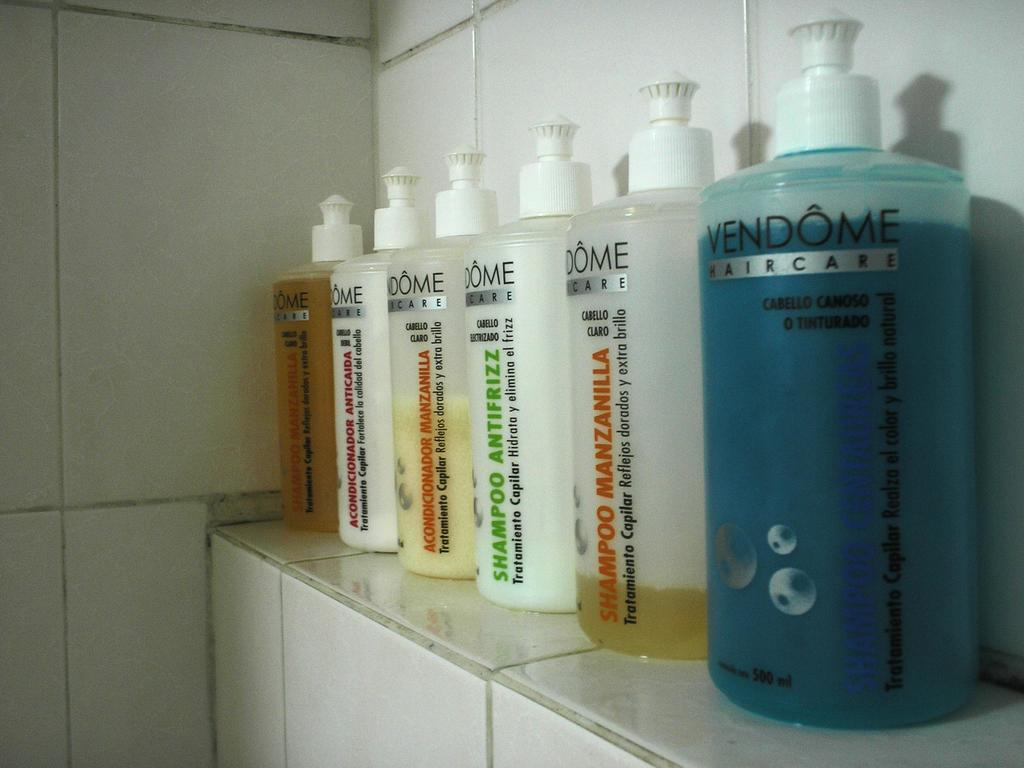<image>
Offer a succinct explanation of the picture presented. bottles of Vendome Haircare lined up on a bathroom shelf 